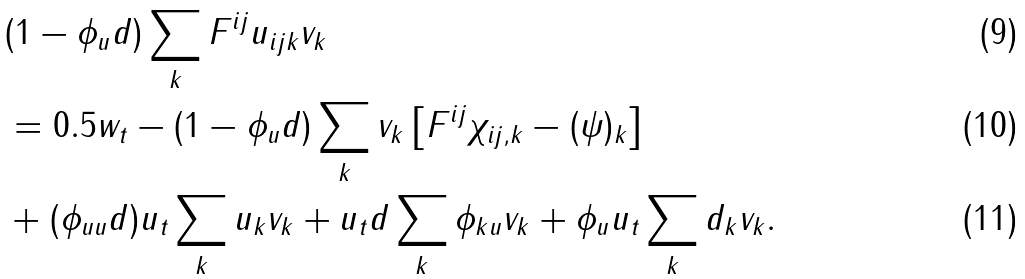Convert formula to latex. <formula><loc_0><loc_0><loc_500><loc_500>& ( 1 - \phi _ { u } d ) \sum _ { k } F ^ { i j } u _ { i j k } v _ { k } \\ & = 0 . 5 w _ { t } - ( 1 - \phi _ { u } d ) \sum _ { k } v _ { k } \left [ F ^ { i j } \chi _ { i j , k } - ( \psi ) _ { k } \right ] \\ & + ( \phi _ { u u } d ) u _ { t } \sum _ { k } u _ { k } v _ { k } + u _ { t } d \sum _ { k } \phi _ { k u } v _ { k } + \phi _ { u } u _ { t } \sum _ { k } d _ { k } v _ { k } .</formula> 